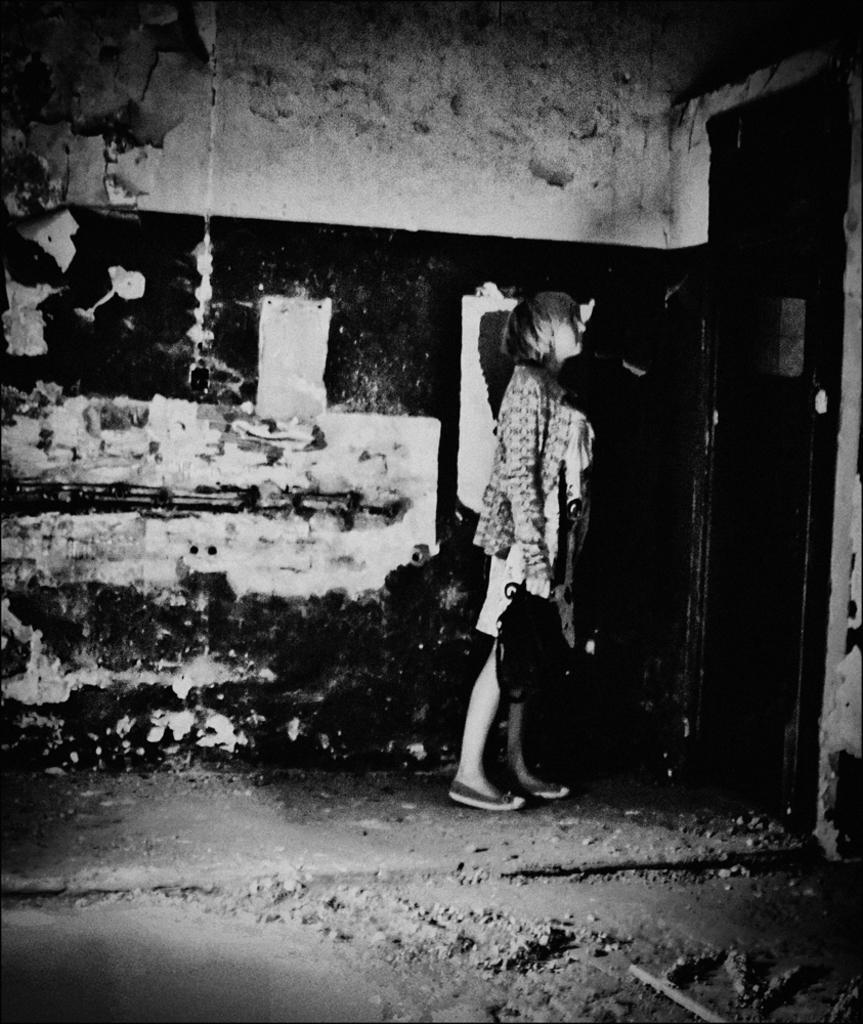Please provide a concise description of this image. This is a black and white image, in this image there is a person standing on a floor, in the background there is a wall. 